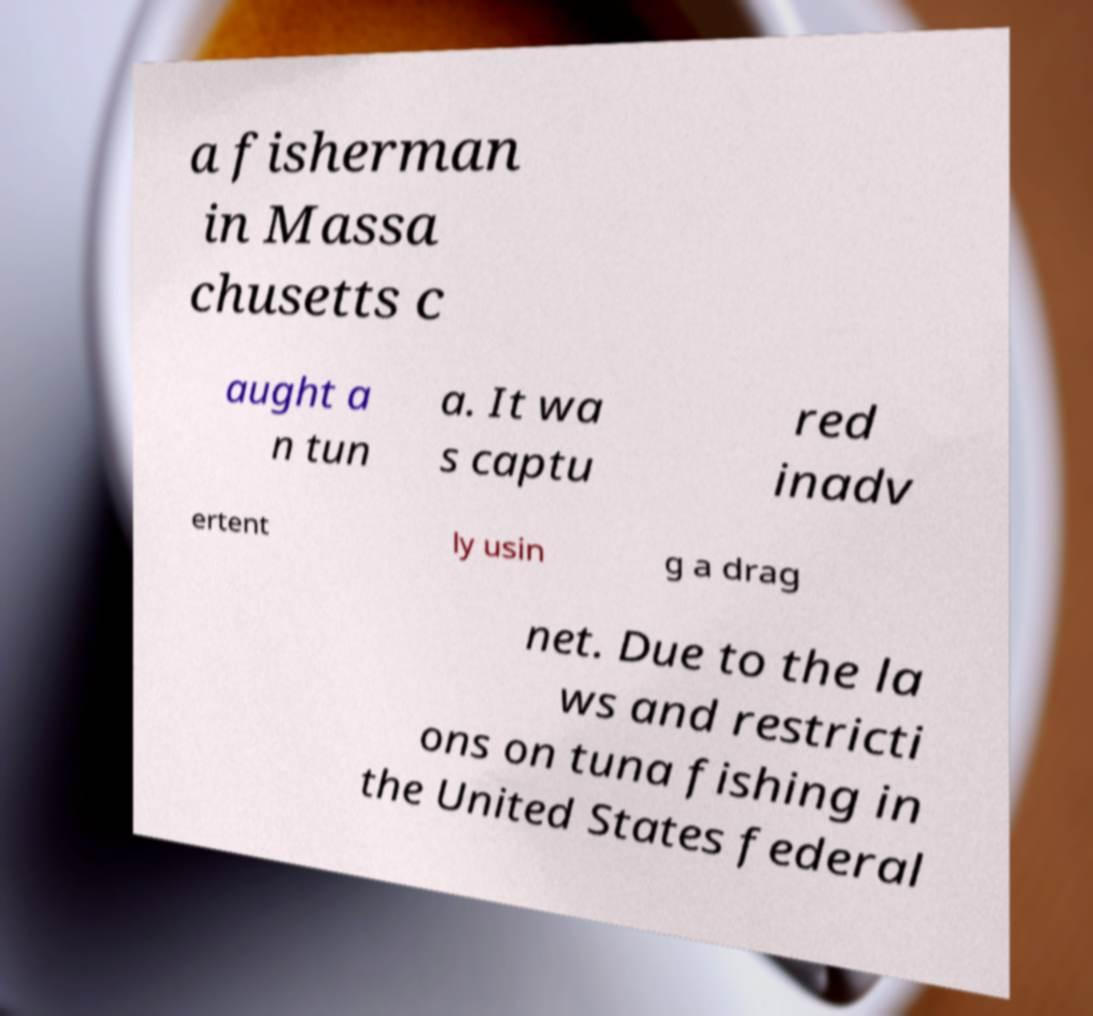Can you accurately transcribe the text from the provided image for me? a fisherman in Massa chusetts c aught a n tun a. It wa s captu red inadv ertent ly usin g a drag net. Due to the la ws and restricti ons on tuna fishing in the United States federal 